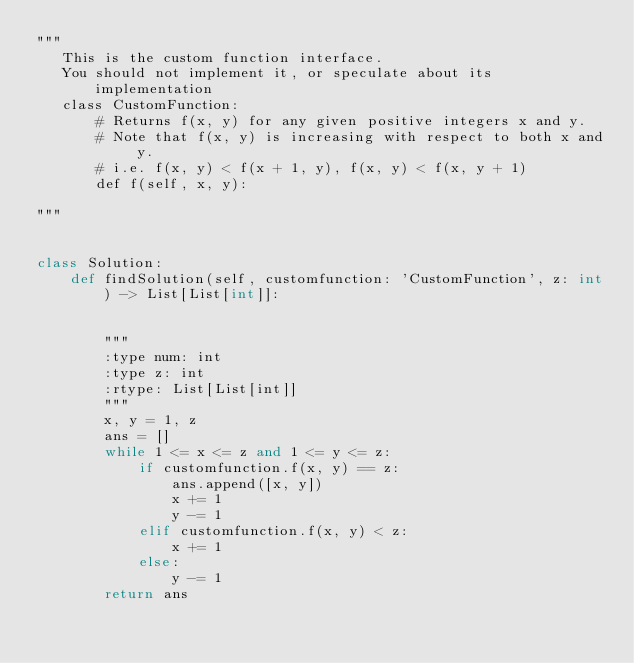<code> <loc_0><loc_0><loc_500><loc_500><_Python_>"""
   This is the custom function interface.
   You should not implement it, or speculate about its implementation
   class CustomFunction:
       # Returns f(x, y) for any given positive integers x and y.
       # Note that f(x, y) is increasing with respect to both x and y.
       # i.e. f(x, y) < f(x + 1, y), f(x, y) < f(x, y + 1)
       def f(self, x, y):

"""


class Solution:
    def findSolution(self, customfunction: 'CustomFunction', z: int) -> List[List[int]]:


        """
        :type num: int
        :type z: int
        :rtype: List[List[int]]
        """
        x, y = 1, z
        ans = []
        while 1 <= x <= z and 1 <= y <= z:
            if customfunction.f(x, y) == z:
                ans.append([x, y])
                x += 1
                y -= 1
            elif customfunction.f(x, y) < z:
                x += 1
            else:
                y -= 1
        return ans
</code> 